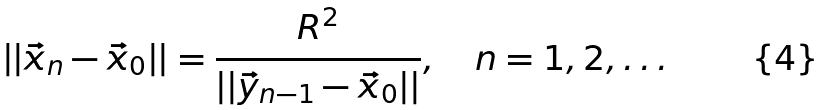Convert formula to latex. <formula><loc_0><loc_0><loc_500><loc_500>| | \vec { x } _ { n } - \vec { x } _ { 0 } | | = \frac { R ^ { 2 } } { | | \vec { y } _ { n - 1 } - \vec { x } _ { 0 } | | } , \quad n = 1 , 2 , \dots</formula> 